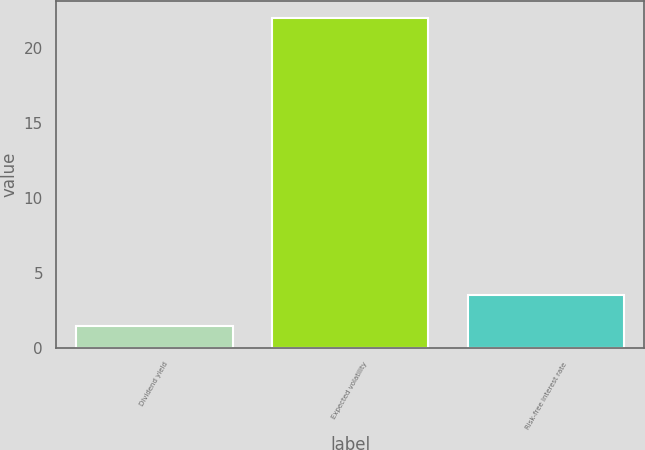Convert chart to OTSL. <chart><loc_0><loc_0><loc_500><loc_500><bar_chart><fcel>Dividend yield<fcel>Expected volatility<fcel>Risk-free interest rate<nl><fcel>1.49<fcel>22<fcel>3.54<nl></chart> 